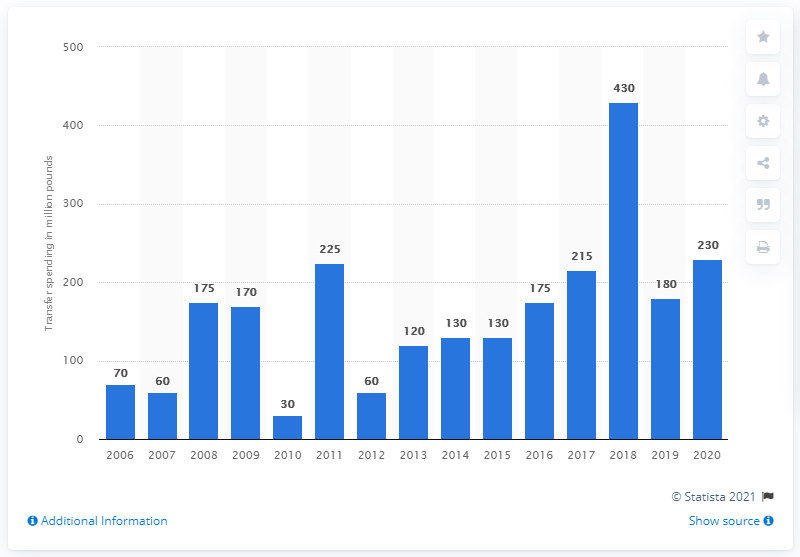Draw attention to some important aspects in this diagram. During January 2020, the total amount of money spent by Premier League clubs on transfers was 230 million. 